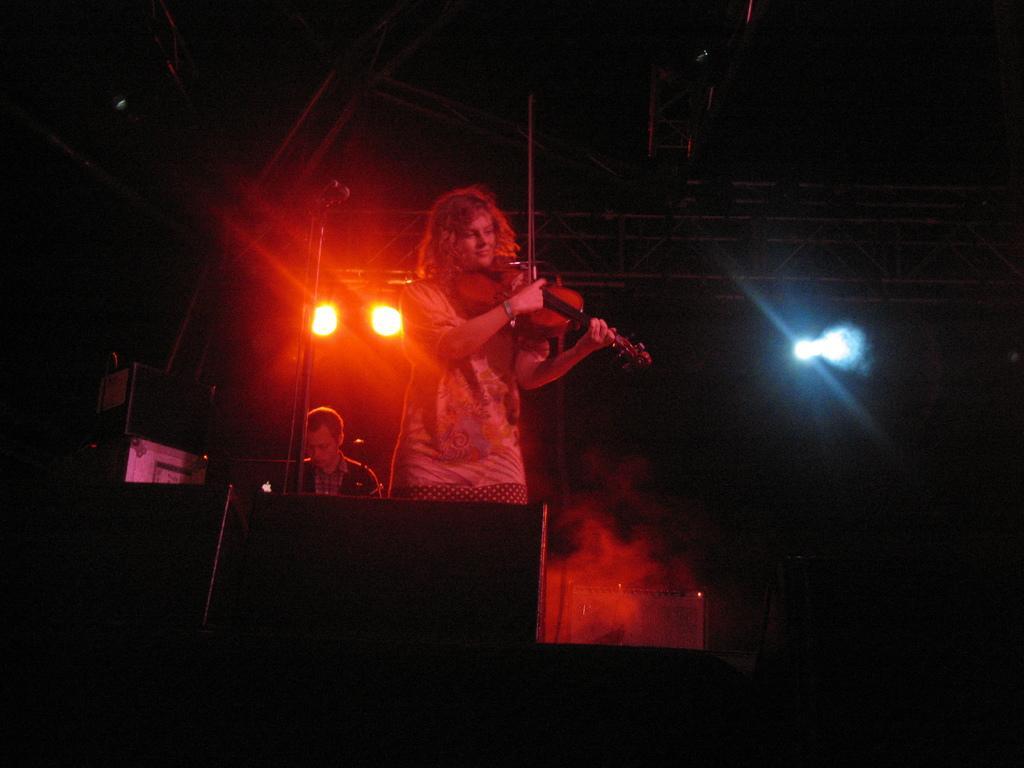Could you give a brief overview of what you see in this image? A person is standing and playing violin. There is another person sitting at the back. There are lights at the top and there is smoke. 